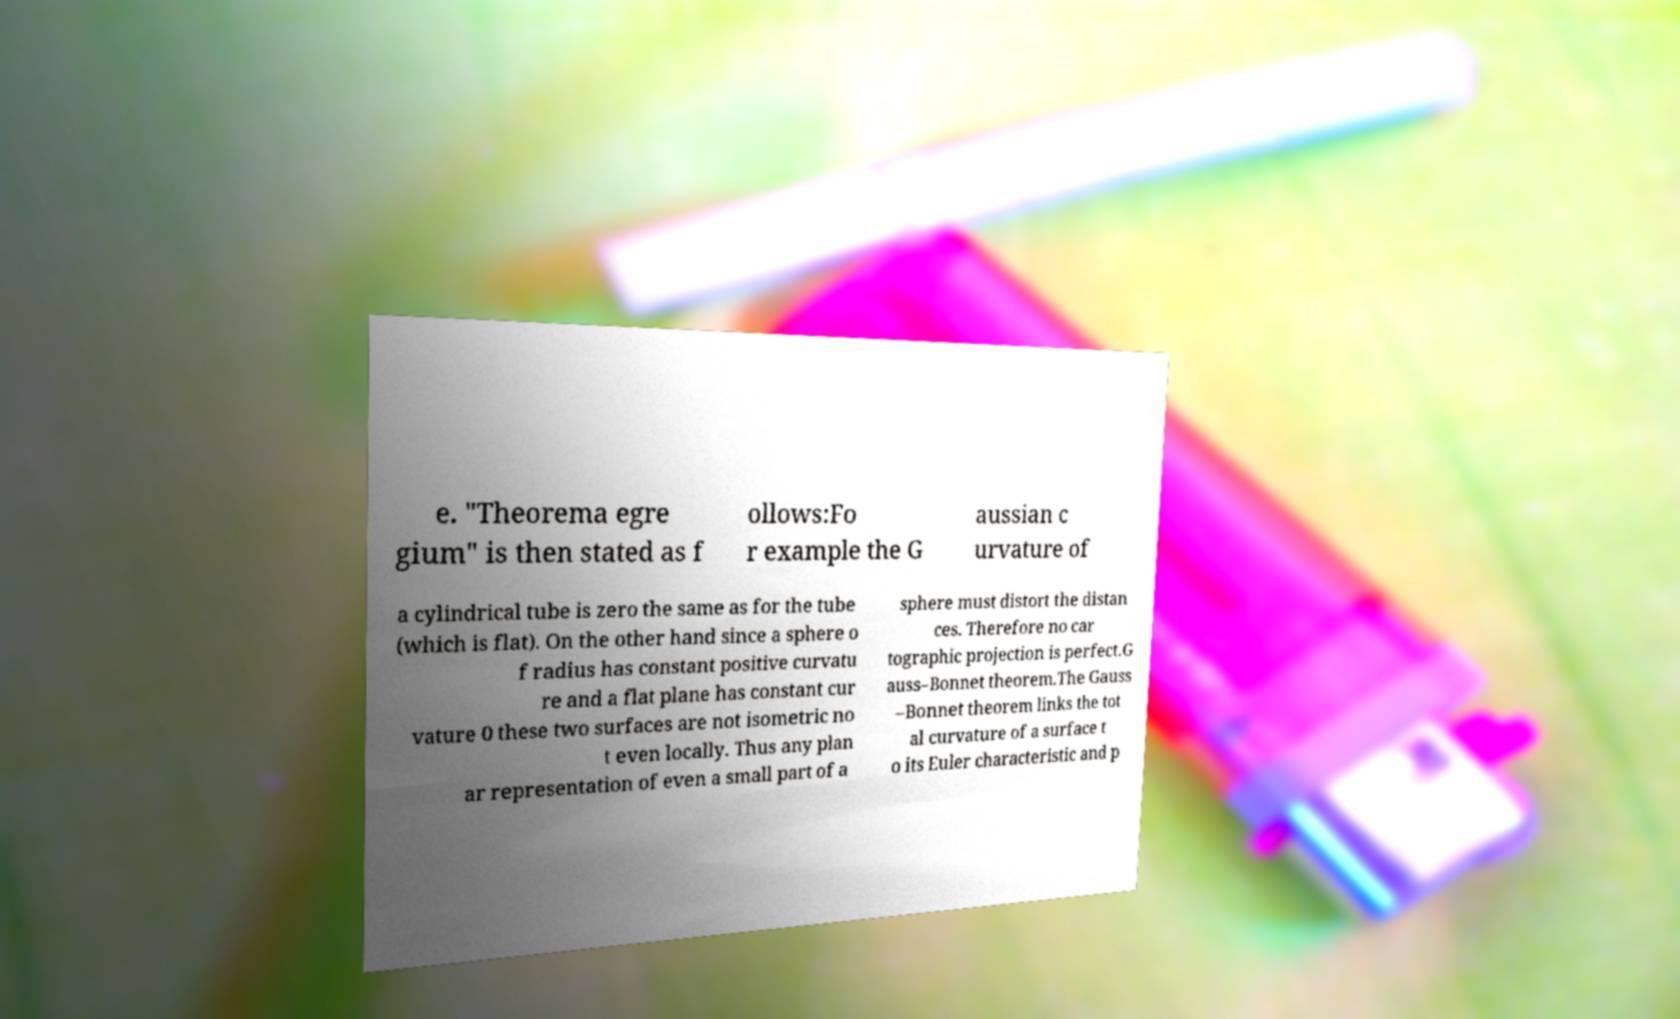There's text embedded in this image that I need extracted. Can you transcribe it verbatim? e. "Theorema egre gium" is then stated as f ollows:Fo r example the G aussian c urvature of a cylindrical tube is zero the same as for the tube (which is flat). On the other hand since a sphere o f radius has constant positive curvatu re and a flat plane has constant cur vature 0 these two surfaces are not isometric no t even locally. Thus any plan ar representation of even a small part of a sphere must distort the distan ces. Therefore no car tographic projection is perfect.G auss–Bonnet theorem.The Gauss –Bonnet theorem links the tot al curvature of a surface t o its Euler characteristic and p 